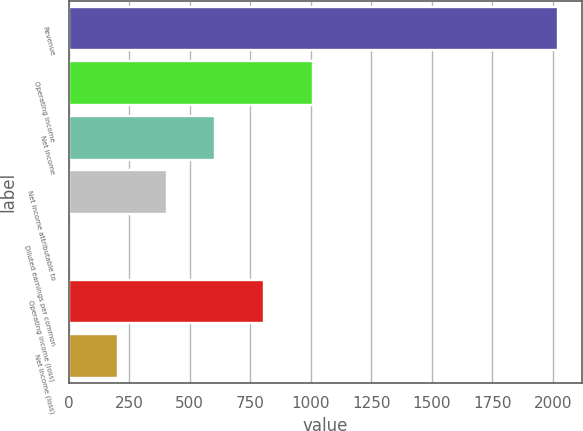Convert chart to OTSL. <chart><loc_0><loc_0><loc_500><loc_500><bar_chart><fcel>Revenue<fcel>Operating income<fcel>Net income<fcel>Net income attributable to<fcel>Diluted earnings per common<fcel>Operating income (loss)<fcel>Net income (loss)<nl><fcel>2020.8<fcel>1010.58<fcel>606.5<fcel>404.46<fcel>0.38<fcel>808.54<fcel>202.42<nl></chart> 